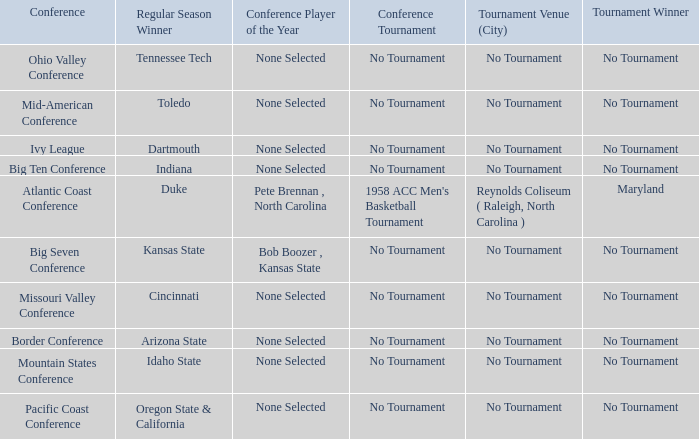Who was the winner of the regular season when the missouri valley conference occurred? Cincinnati. 